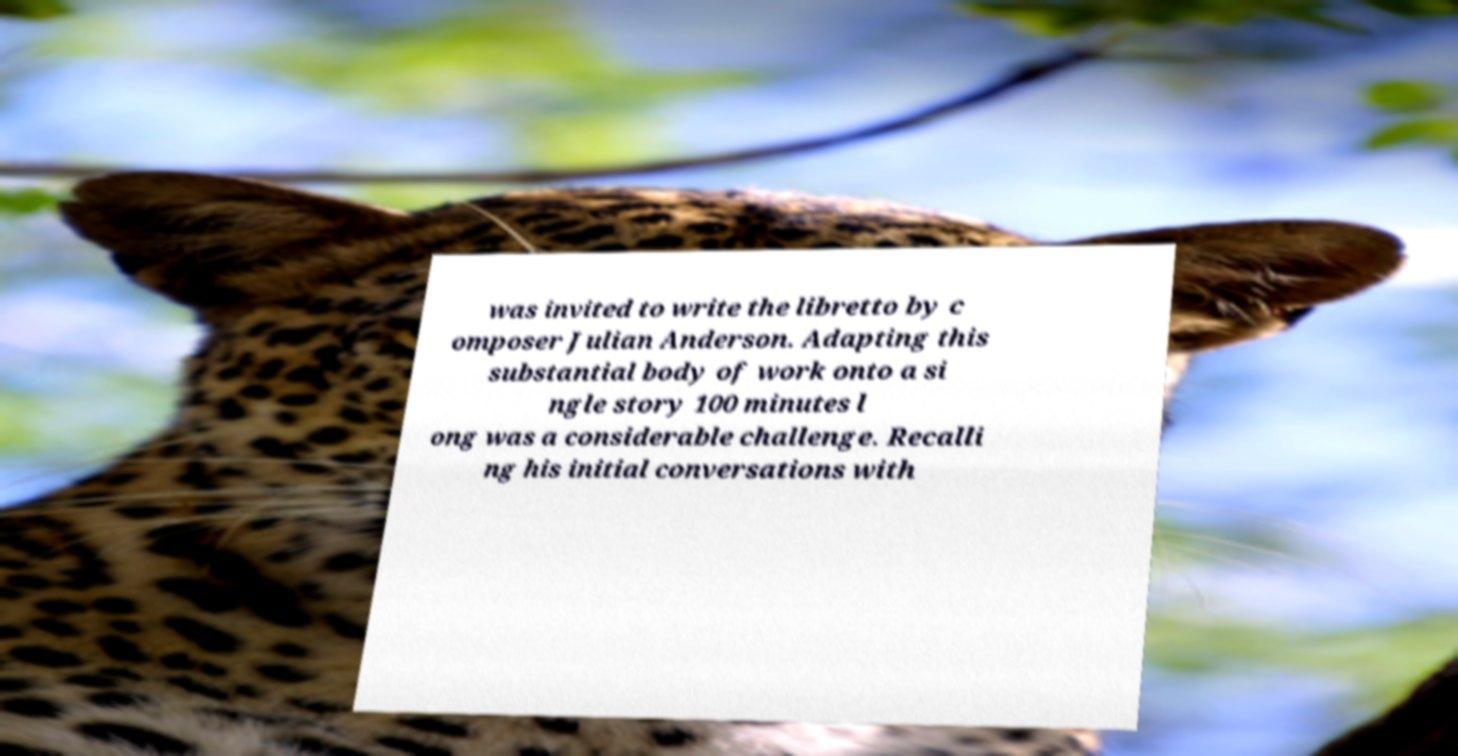Please read and relay the text visible in this image. What does it say? was invited to write the libretto by c omposer Julian Anderson. Adapting this substantial body of work onto a si ngle story 100 minutes l ong was a considerable challenge. Recalli ng his initial conversations with 